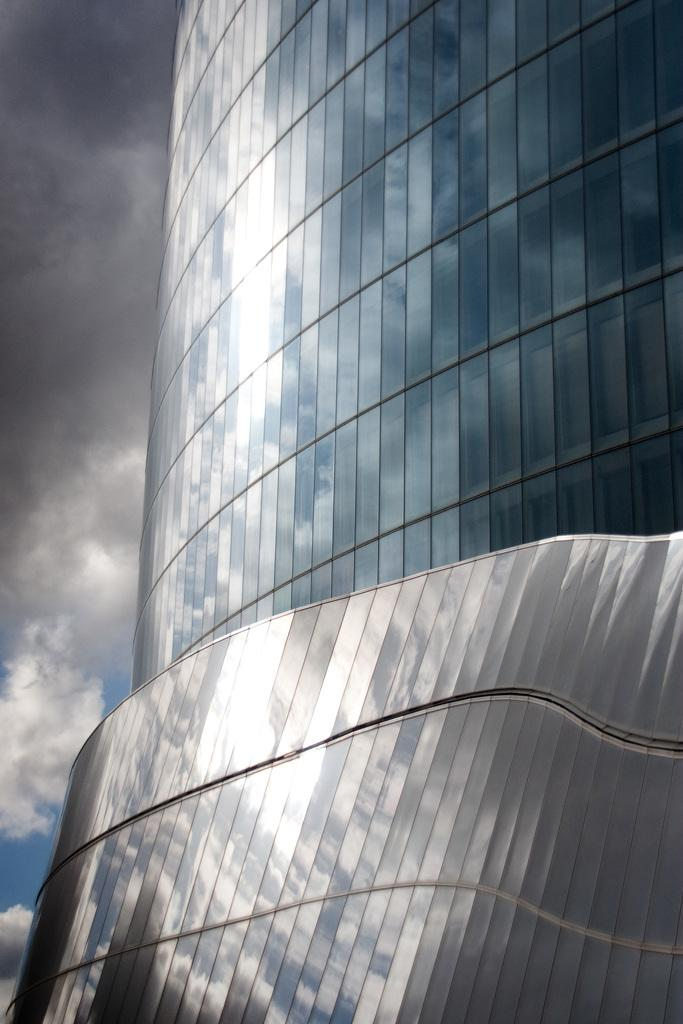What type of structure is visible in the image? There is a building in the image. What can be seen in the background of the image? The sky is visible in the background of the image. What is the condition of the sky in the image? Clouds are present in the sky. How many tomatoes are hanging from the pencil in the image? There are no tomatoes or pencils present in the image. 